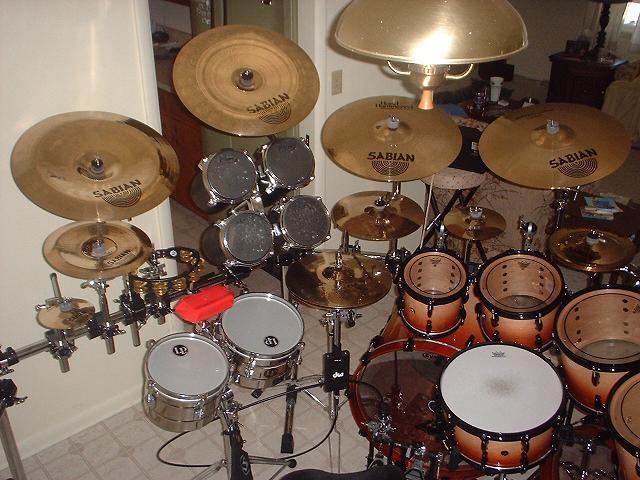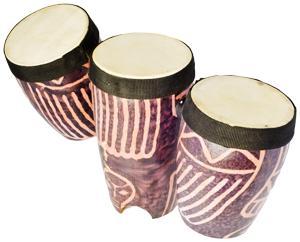The first image is the image on the left, the second image is the image on the right. For the images displayed, is the sentence "The right image shows a row of at least three white-topped drums with black around at least part of their sides and no cymbals." factually correct? Answer yes or no. Yes. 